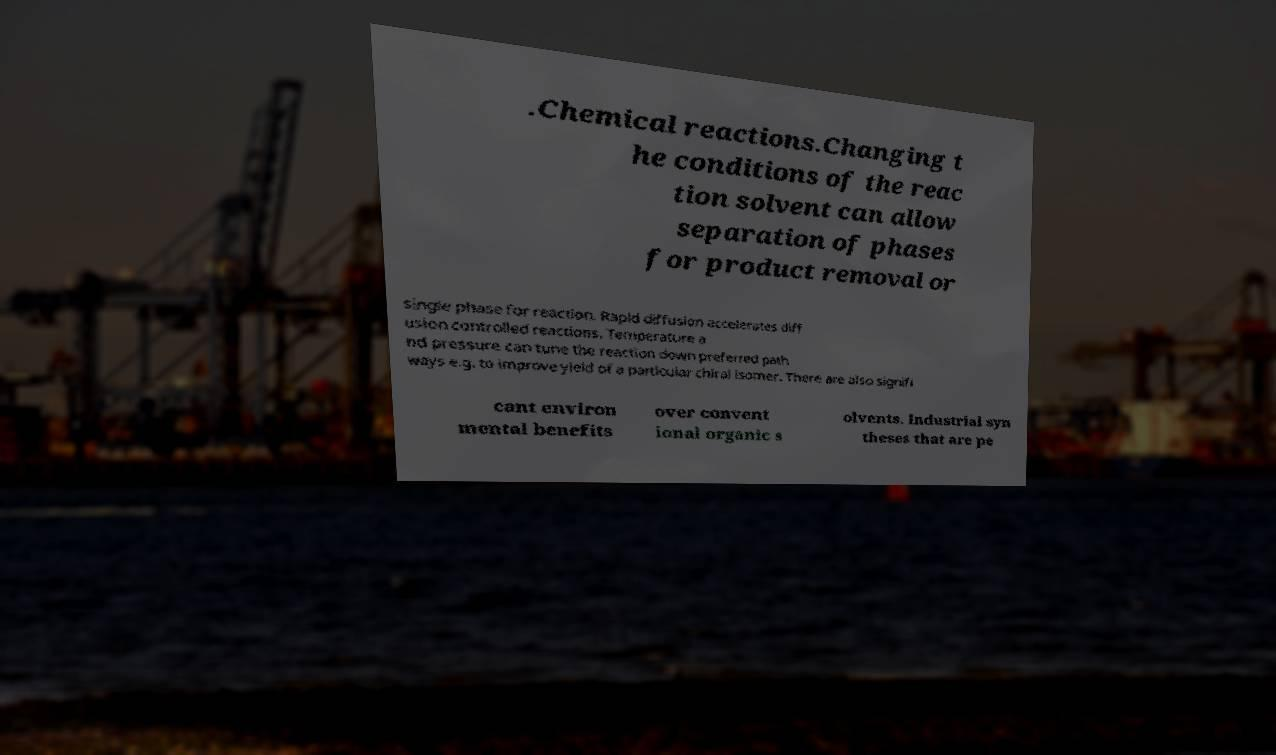Can you read and provide the text displayed in the image?This photo seems to have some interesting text. Can you extract and type it out for me? .Chemical reactions.Changing t he conditions of the reac tion solvent can allow separation of phases for product removal or single phase for reaction. Rapid diffusion accelerates diff usion controlled reactions. Temperature a nd pressure can tune the reaction down preferred path ways e.g. to improve yield of a particular chiral isomer. There are also signifi cant environ mental benefits over convent ional organic s olvents. Industrial syn theses that are pe 